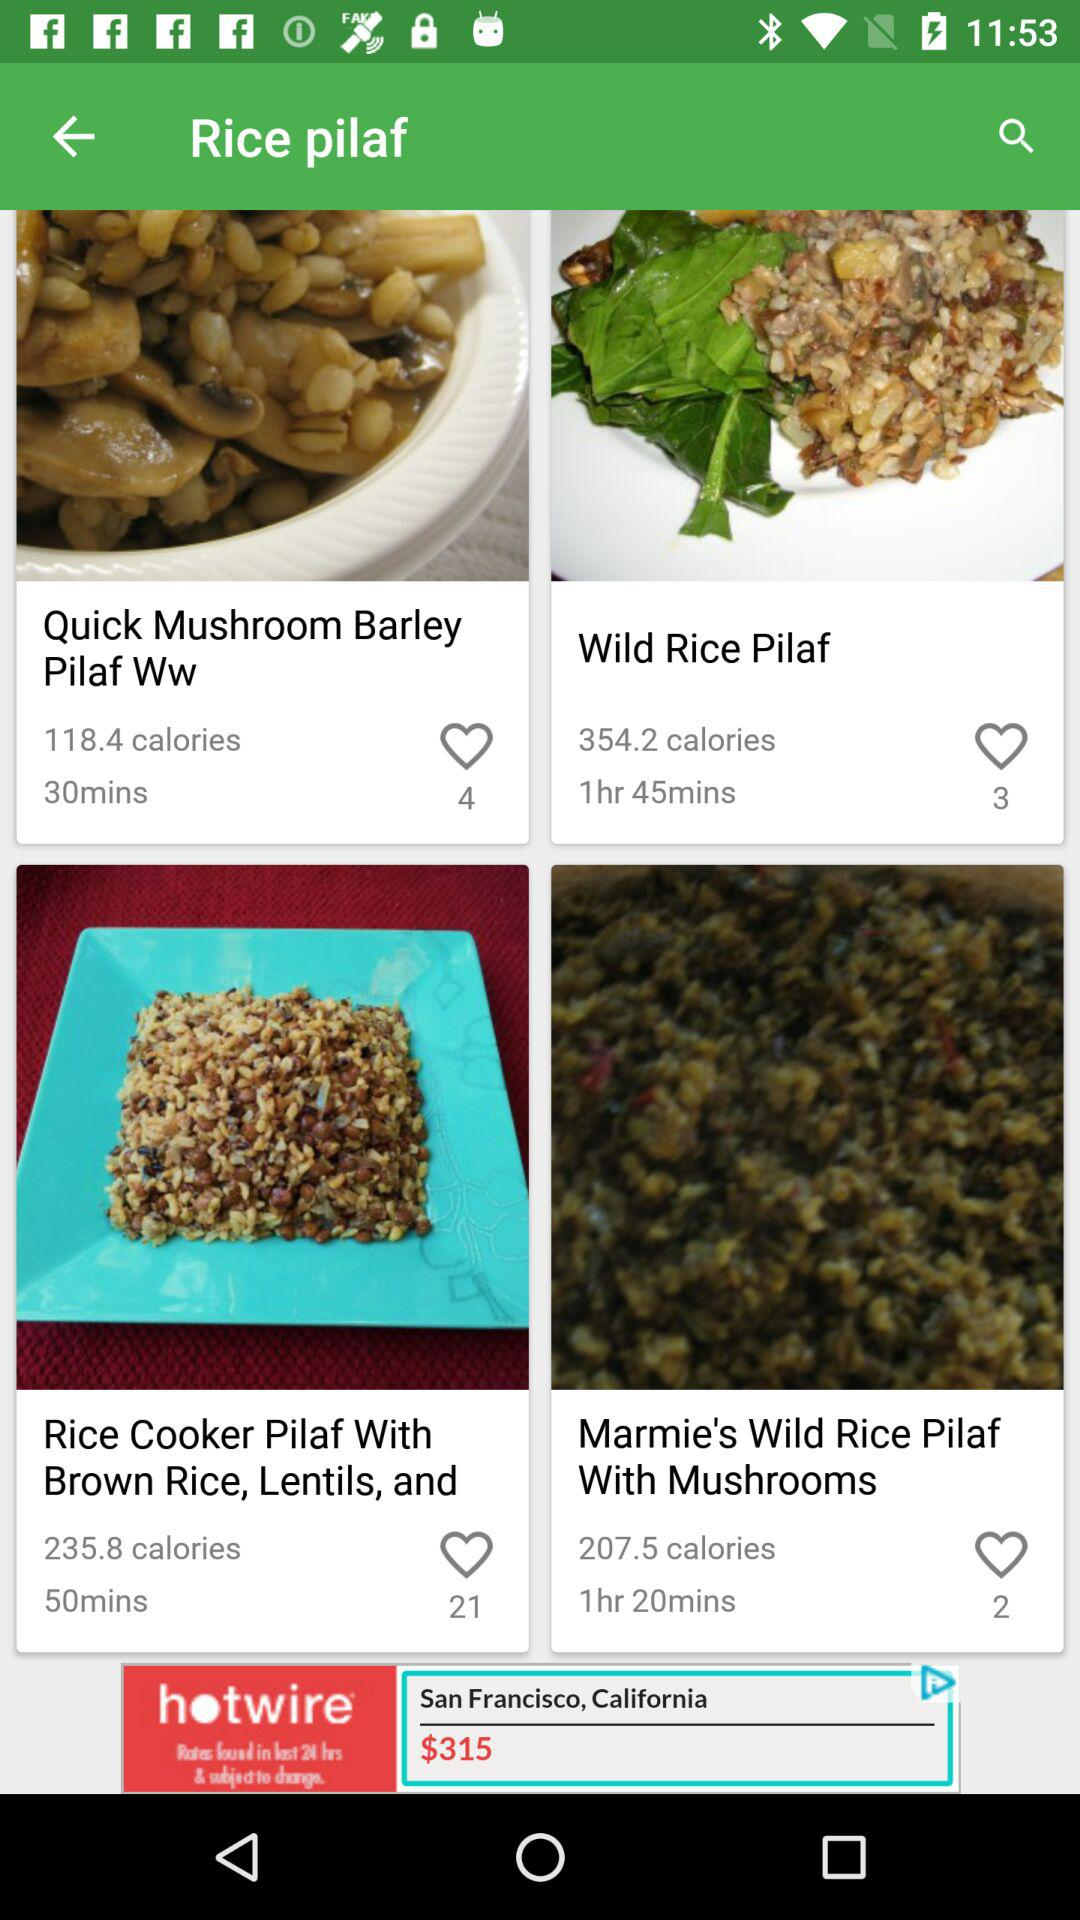What is the cooking time for "Marmie's Wild Rice Pilaf With Mushrooms"? The cooking time is 1 hour and 20 minutes. 